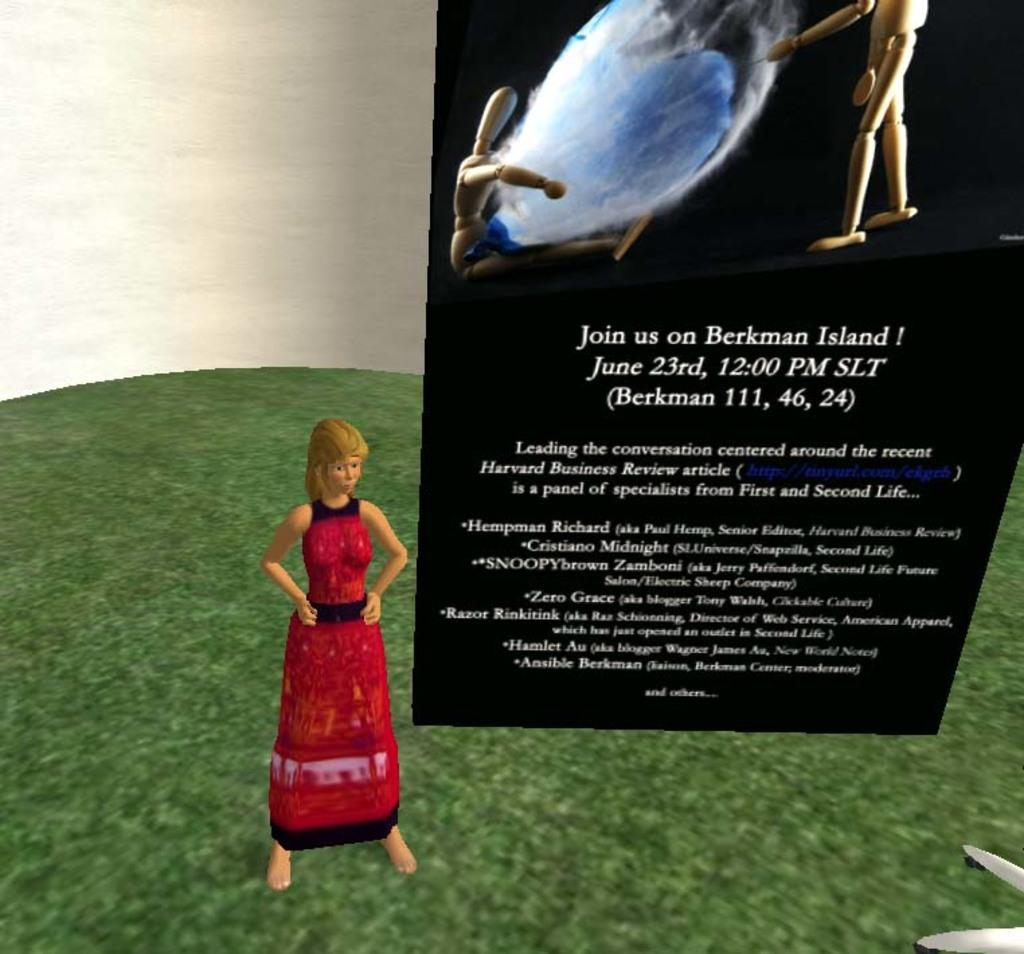What type of image is this? The image is animated. Can you describe the woman on the left side of the image? There is a woman on the left side of the image, but no specific details about her appearance are provided. What is on the right side of the image? There is a poster on the right side of the image. What can be found on the poster? The poster contains text and images of toys. What is at the bottom of the image? There is grass at the bottom of the image. What type of copper material is used to create the woman's dress in the image? There is no mention of copper or any specific materials used in the image. The woman's dress is not described in detail. What kind of marble is visible in the image? There is no mention of marble or any stone-like materials in the image. The image is animated and does not depict real-world materials. 